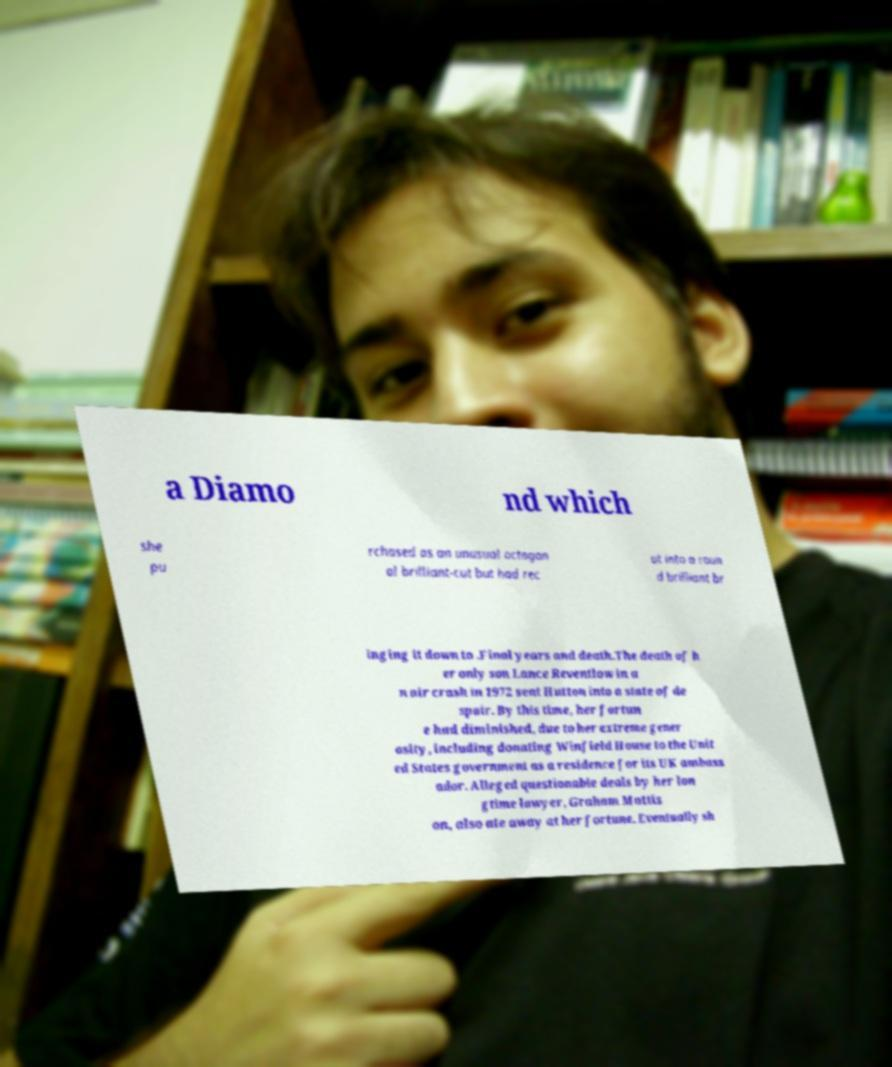Could you assist in decoding the text presented in this image and type it out clearly? a Diamo nd which she pu rchased as an unusual octagon al brilliant-cut but had rec ut into a roun d brilliant br inging it down to .Final years and death.The death of h er only son Lance Reventlow in a n air crash in 1972 sent Hutton into a state of de spair. By this time, her fortun e had diminished, due to her extreme gener osity, including donating Winfield House to the Unit ed States government as a residence for its UK ambass ador. Alleged questionable deals by her lon gtime lawyer, Graham Mattis on, also ate away at her fortune. Eventually sh 